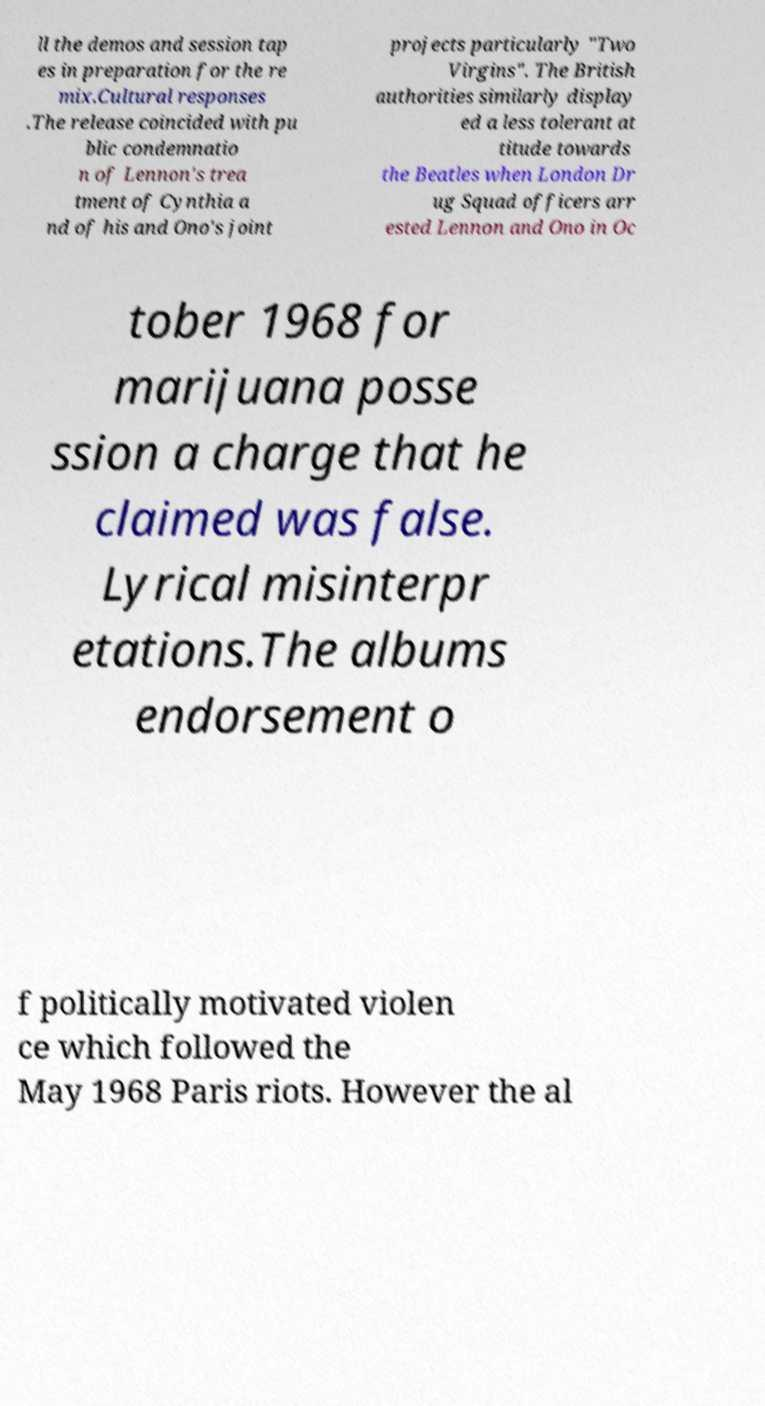What messages or text are displayed in this image? I need them in a readable, typed format. ll the demos and session tap es in preparation for the re mix.Cultural responses .The release coincided with pu blic condemnatio n of Lennon's trea tment of Cynthia a nd of his and Ono's joint projects particularly "Two Virgins". The British authorities similarly display ed a less tolerant at titude towards the Beatles when London Dr ug Squad officers arr ested Lennon and Ono in Oc tober 1968 for marijuana posse ssion a charge that he claimed was false. Lyrical misinterpr etations.The albums endorsement o f politically motivated violen ce which followed the May 1968 Paris riots. However the al 